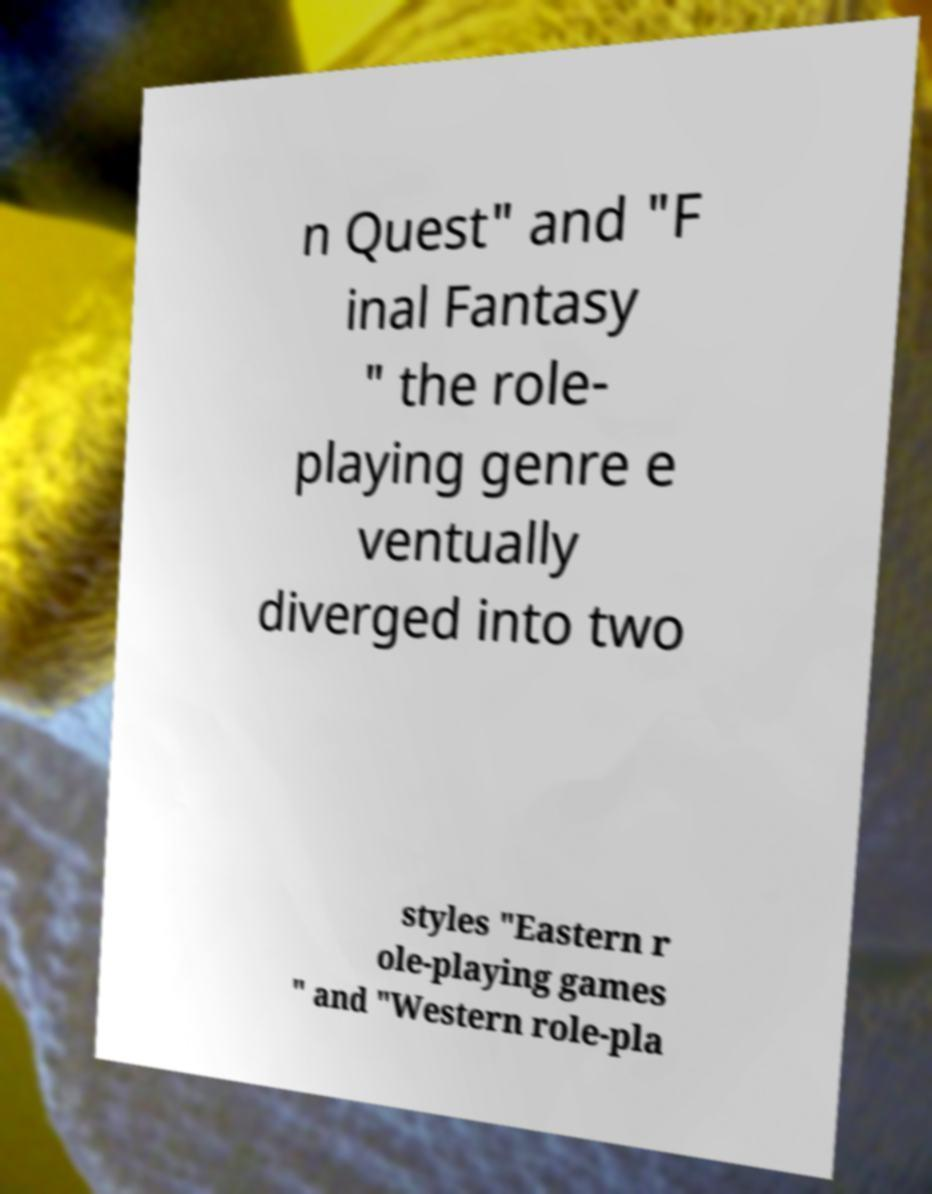What messages or text are displayed in this image? I need them in a readable, typed format. n Quest" and "F inal Fantasy " the role- playing genre e ventually diverged into two styles "Eastern r ole-playing games " and "Western role-pla 